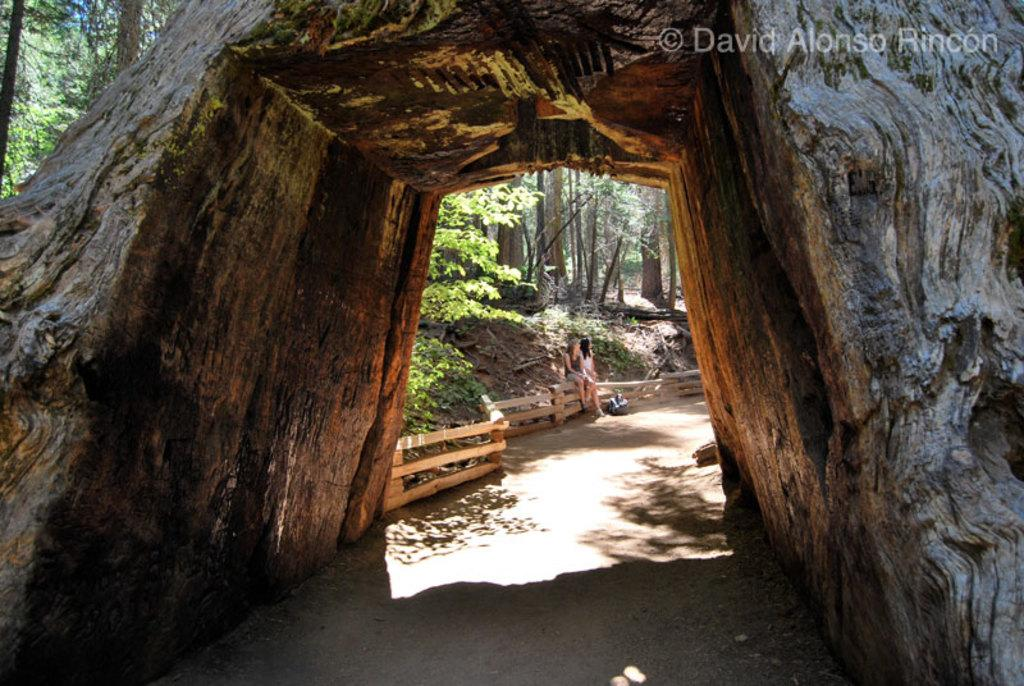What is the main structure visible in the front of the image? There is a tunnel in the front of the image. How many people are in the image? There are two persons in the image. What are the persons doing in the image? The persons are sitting on a wooden fence. What can be seen behind the persons? Trees are visible behind the persons. What type of soap is being used by the persons in the image? There is no soap present in the image; the persons are sitting on a wooden fence. What story are the persons discussing while sitting on the fence? There is no indication in the image that the persons are discussing a story or any specific topic. 